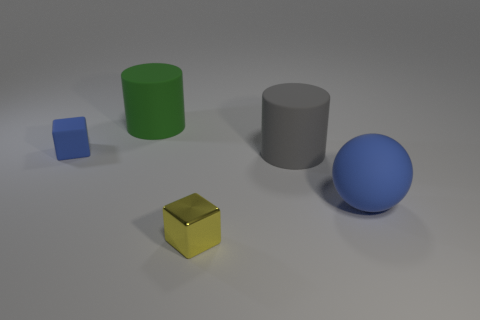There is a ball that is the same material as the tiny blue thing; what is its color?
Provide a short and direct response. Blue. What number of blue objects are matte cubes or big balls?
Offer a very short reply. 2. Is the number of small red spheres greater than the number of small blue matte things?
Make the answer very short. No. How many things are either tiny blocks behind the big blue rubber thing or blue objects that are left of the gray cylinder?
Your response must be concise. 1. What is the color of the cube that is the same size as the metallic object?
Offer a terse response. Blue. Does the big blue sphere have the same material as the blue block?
Keep it short and to the point. Yes. What is the small object that is right of the tiny thing that is to the left of the green rubber object made of?
Give a very brief answer. Metal. Is the number of big rubber things on the left side of the shiny thing greater than the number of big brown metal spheres?
Give a very brief answer. Yes. How many other things are there of the same size as the green cylinder?
Keep it short and to the point. 2. Is the color of the large ball the same as the metallic object?
Offer a terse response. No. 